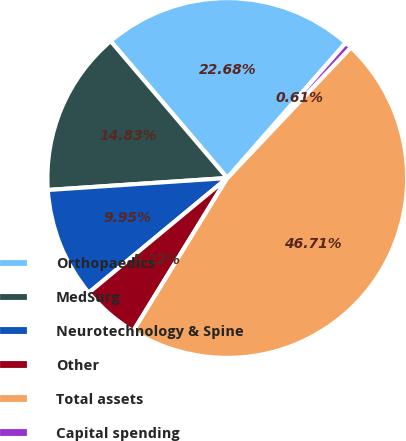<chart> <loc_0><loc_0><loc_500><loc_500><pie_chart><fcel>Orthopaedics<fcel>MedSurg<fcel>Neurotechnology & Spine<fcel>Other<fcel>Total assets<fcel>Capital spending<nl><fcel>22.68%<fcel>14.83%<fcel>9.95%<fcel>5.22%<fcel>46.71%<fcel>0.61%<nl></chart> 